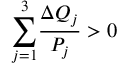<formula> <loc_0><loc_0><loc_500><loc_500>{ \sum _ { j = 1 } ^ { 3 } } \frac { \Delta Q _ { j } } { P _ { j } } > 0</formula> 